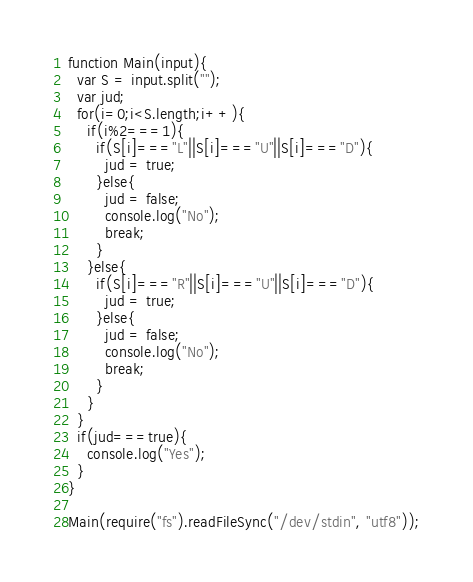<code> <loc_0><loc_0><loc_500><loc_500><_JavaScript_>function Main(input){
  var S = input.split("");
  var jud;
  for(i=0;i<S.length;i++){
    if(i%2===1){
      if(S[i]==="L"||S[i]==="U"||S[i]==="D"){
        jud = true;
      }else{
        jud = false;
        console.log("No");
        break;
      }
    }else{
      if(S[i]==="R"||S[i]==="U"||S[i]==="D"){
        jud = true;
      }else{
        jud = false;
        console.log("No");
        break;
      }
    }
  }
  if(jud===true){
    console.log("Yes");
  }
}
 
Main(require("fs").readFileSync("/dev/stdin", "utf8"));


</code> 